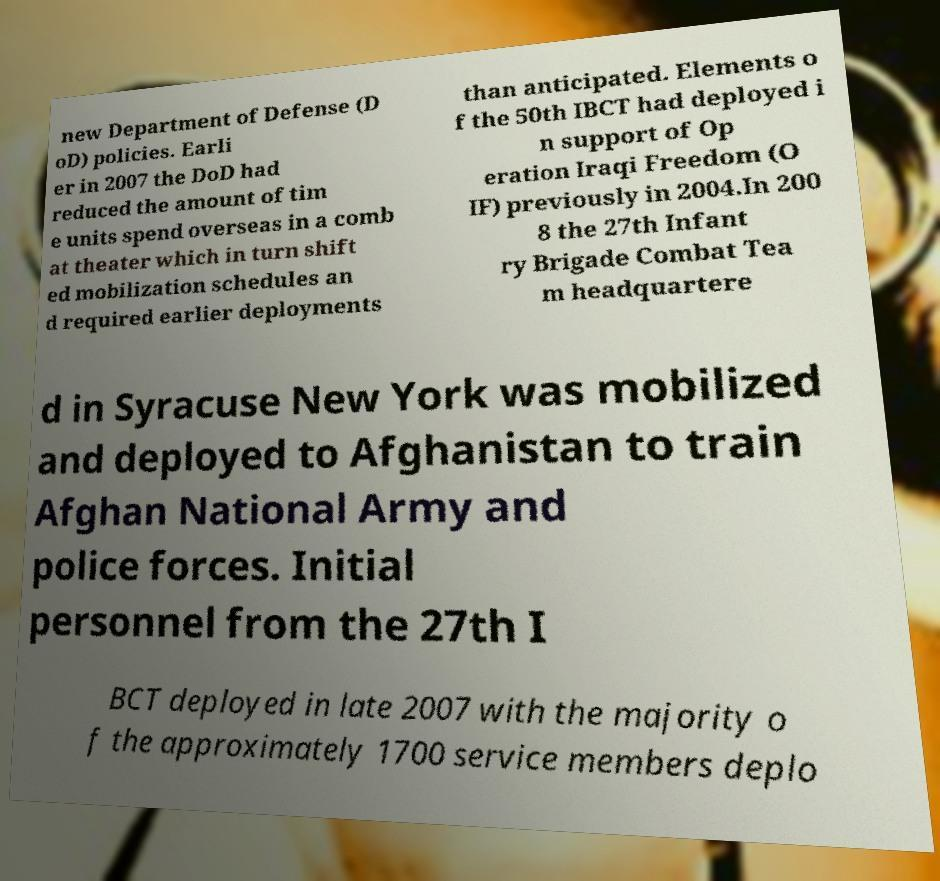Could you assist in decoding the text presented in this image and type it out clearly? new Department of Defense (D oD) policies. Earli er in 2007 the DoD had reduced the amount of tim e units spend overseas in a comb at theater which in turn shift ed mobilization schedules an d required earlier deployments than anticipated. Elements o f the 50th IBCT had deployed i n support of Op eration Iraqi Freedom (O IF) previously in 2004.In 200 8 the 27th Infant ry Brigade Combat Tea m headquartere d in Syracuse New York was mobilized and deployed to Afghanistan to train Afghan National Army and police forces. Initial personnel from the 27th I BCT deployed in late 2007 with the majority o f the approximately 1700 service members deplo 